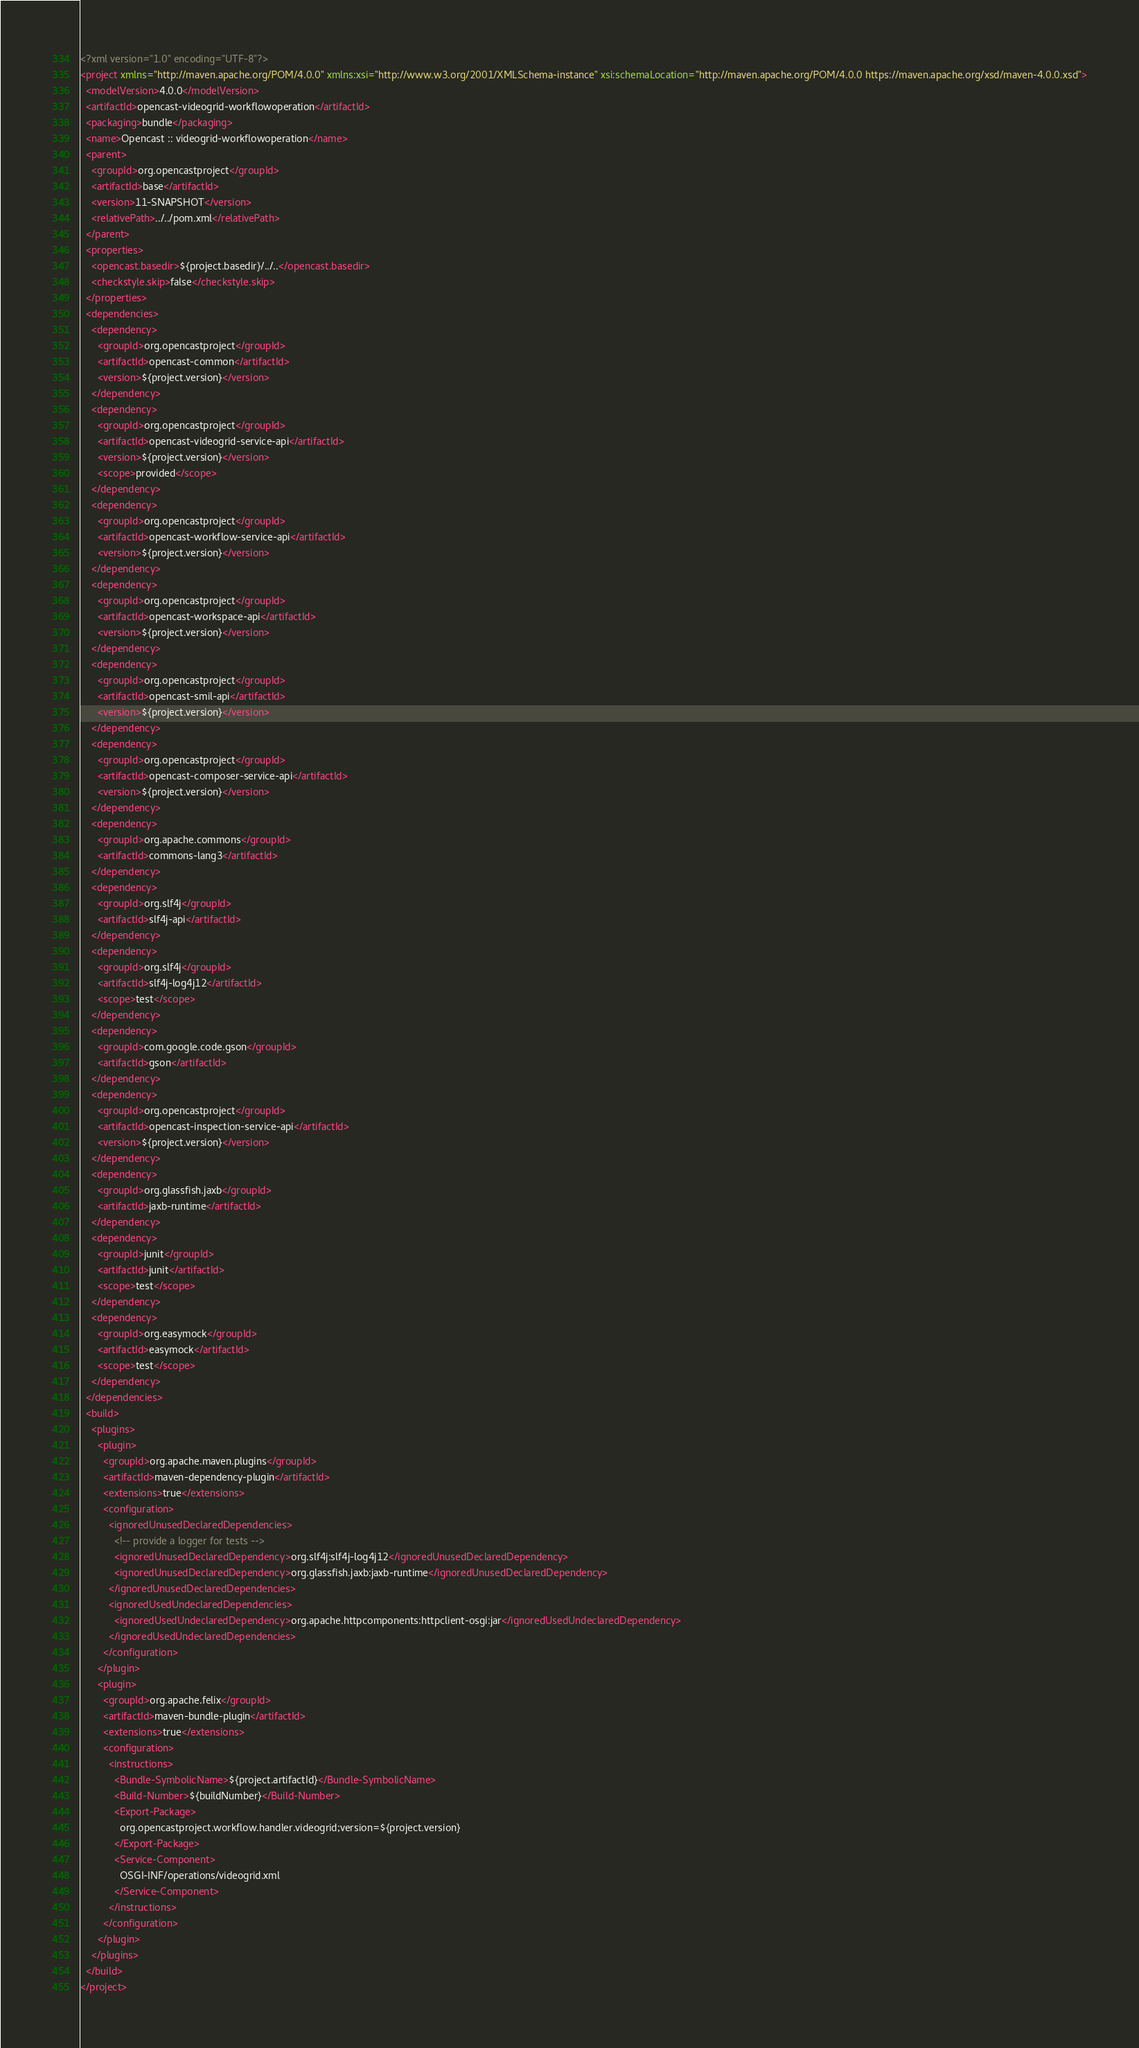Convert code to text. <code><loc_0><loc_0><loc_500><loc_500><_XML_><?xml version="1.0" encoding="UTF-8"?>
<project xmlns="http://maven.apache.org/POM/4.0.0" xmlns:xsi="http://www.w3.org/2001/XMLSchema-instance" xsi:schemaLocation="http://maven.apache.org/POM/4.0.0 https://maven.apache.org/xsd/maven-4.0.0.xsd">
  <modelVersion>4.0.0</modelVersion>
  <artifactId>opencast-videogrid-workflowoperation</artifactId>
  <packaging>bundle</packaging>
  <name>Opencast :: videogrid-workflowoperation</name>
  <parent>
    <groupId>org.opencastproject</groupId>
    <artifactId>base</artifactId>
    <version>11-SNAPSHOT</version>
    <relativePath>../../pom.xml</relativePath>
  </parent>
  <properties>
    <opencast.basedir>${project.basedir}/../..</opencast.basedir>
    <checkstyle.skip>false</checkstyle.skip>
  </properties>
  <dependencies>
    <dependency>
      <groupId>org.opencastproject</groupId>
      <artifactId>opencast-common</artifactId>
      <version>${project.version}</version>
    </dependency>
    <dependency>
      <groupId>org.opencastproject</groupId>
      <artifactId>opencast-videogrid-service-api</artifactId>
      <version>${project.version}</version>
      <scope>provided</scope>
    </dependency>
    <dependency>
      <groupId>org.opencastproject</groupId>
      <artifactId>opencast-workflow-service-api</artifactId>
      <version>${project.version}</version>
    </dependency>
    <dependency>
      <groupId>org.opencastproject</groupId>
      <artifactId>opencast-workspace-api</artifactId>
      <version>${project.version}</version>
    </dependency>
    <dependency>
      <groupId>org.opencastproject</groupId>
      <artifactId>opencast-smil-api</artifactId>
      <version>${project.version}</version>
    </dependency>
    <dependency>
      <groupId>org.opencastproject</groupId>
      <artifactId>opencast-composer-service-api</artifactId>
      <version>${project.version}</version>
    </dependency>
    <dependency>
      <groupId>org.apache.commons</groupId>
      <artifactId>commons-lang3</artifactId>
    </dependency>
    <dependency>
      <groupId>org.slf4j</groupId>
      <artifactId>slf4j-api</artifactId>
    </dependency>
    <dependency>
      <groupId>org.slf4j</groupId>
      <artifactId>slf4j-log4j12</artifactId>
      <scope>test</scope>
    </dependency>
    <dependency>
      <groupId>com.google.code.gson</groupId>
      <artifactId>gson</artifactId>
    </dependency>
    <dependency>
      <groupId>org.opencastproject</groupId>
      <artifactId>opencast-inspection-service-api</artifactId>
      <version>${project.version}</version>
    </dependency>
    <dependency>
      <groupId>org.glassfish.jaxb</groupId>
      <artifactId>jaxb-runtime</artifactId>
    </dependency>
    <dependency>
      <groupId>junit</groupId>
      <artifactId>junit</artifactId>
      <scope>test</scope>
    </dependency>
    <dependency>
      <groupId>org.easymock</groupId>
      <artifactId>easymock</artifactId>
      <scope>test</scope>
    </dependency>
  </dependencies>
  <build>
    <plugins>
      <plugin>
        <groupId>org.apache.maven.plugins</groupId>
        <artifactId>maven-dependency-plugin</artifactId>
        <extensions>true</extensions>
        <configuration>
          <ignoredUnusedDeclaredDependencies>
            <!-- provide a logger for tests -->
            <ignoredUnusedDeclaredDependency>org.slf4j:slf4j-log4j12</ignoredUnusedDeclaredDependency>
            <ignoredUnusedDeclaredDependency>org.glassfish.jaxb:jaxb-runtime</ignoredUnusedDeclaredDependency>
          </ignoredUnusedDeclaredDependencies>
          <ignoredUsedUndeclaredDependencies>
            <ignoredUsedUndeclaredDependency>org.apache.httpcomponents:httpclient-osgi:jar</ignoredUsedUndeclaredDependency>
          </ignoredUsedUndeclaredDependencies>
        </configuration>
      </plugin>
      <plugin>
        <groupId>org.apache.felix</groupId>
        <artifactId>maven-bundle-plugin</artifactId>
        <extensions>true</extensions>
        <configuration>
          <instructions>
            <Bundle-SymbolicName>${project.artifactId}</Bundle-SymbolicName>
            <Build-Number>${buildNumber}</Build-Number>
            <Export-Package>
              org.opencastproject.workflow.handler.videogrid;version=${project.version}
            </Export-Package>
            <Service-Component>
              OSGI-INF/operations/videogrid.xml
            </Service-Component>
          </instructions>
        </configuration>
      </plugin>
    </plugins>
  </build>
</project>
</code> 